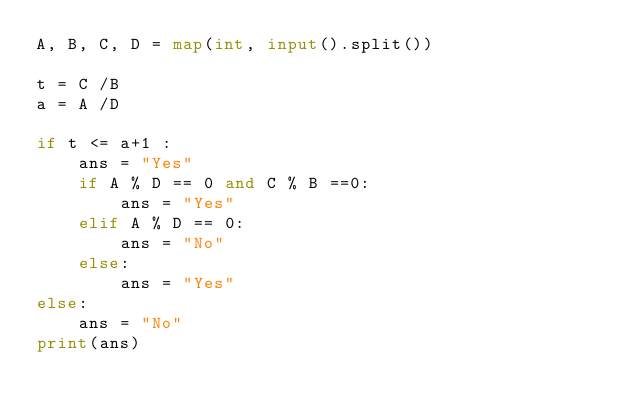Convert code to text. <code><loc_0><loc_0><loc_500><loc_500><_Python_>A, B, C, D = map(int, input().split())

t = C /B
a = A /D

if t <= a+1 :
    ans = "Yes"
    if A % D == 0 and C % B ==0:
        ans = "Yes"
    elif A % D == 0:
        ans = "No"
    else:
        ans = "Yes"
else:
    ans = "No"
print(ans)</code> 